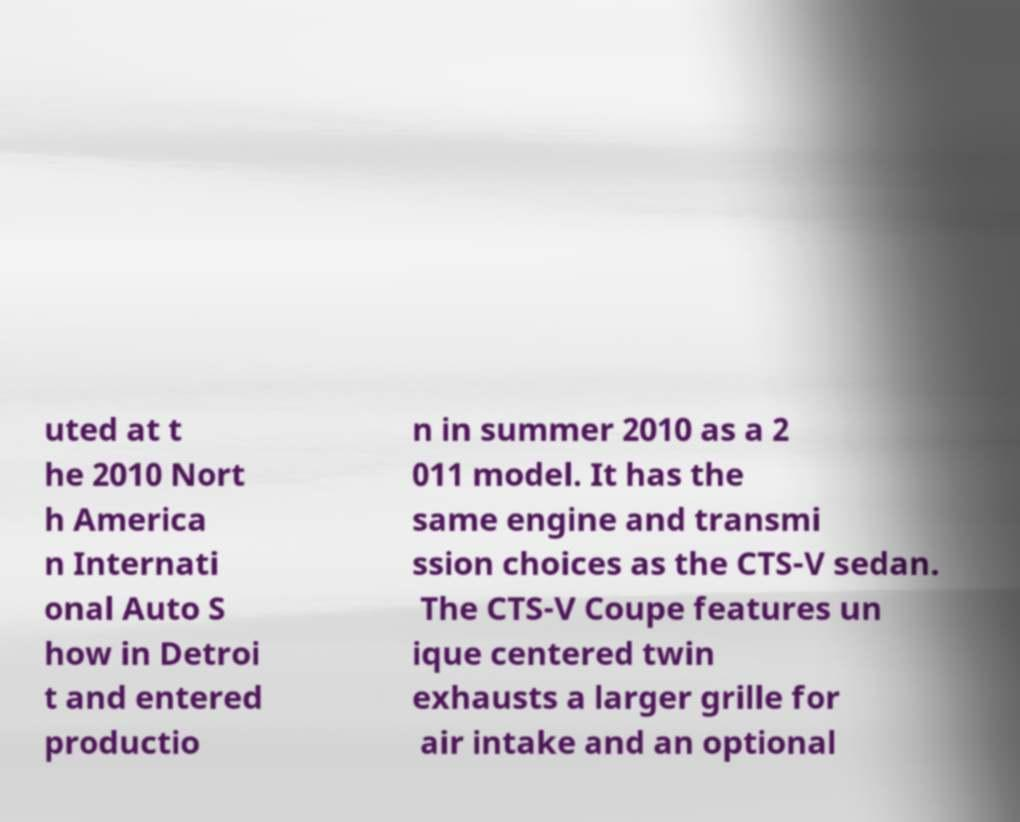There's text embedded in this image that I need extracted. Can you transcribe it verbatim? uted at t he 2010 Nort h America n Internati onal Auto S how in Detroi t and entered productio n in summer 2010 as a 2 011 model. It has the same engine and transmi ssion choices as the CTS-V sedan. The CTS-V Coupe features un ique centered twin exhausts a larger grille for air intake and an optional 